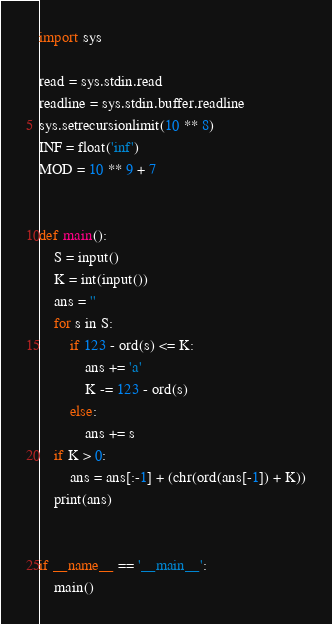<code> <loc_0><loc_0><loc_500><loc_500><_Python_>import sys

read = sys.stdin.read
readline = sys.stdin.buffer.readline
sys.setrecursionlimit(10 ** 8)
INF = float('inf')
MOD = 10 ** 9 + 7


def main():
    S = input()
    K = int(input())
    ans = ''
    for s in S:
        if 123 - ord(s) <= K:
            ans += 'a'
            K -= 123 - ord(s)
        else:
            ans += s
    if K > 0:
        ans = ans[:-1] + (chr(ord(ans[-1]) + K))
    print(ans)


if __name__ == '__main__':
    main()
</code> 